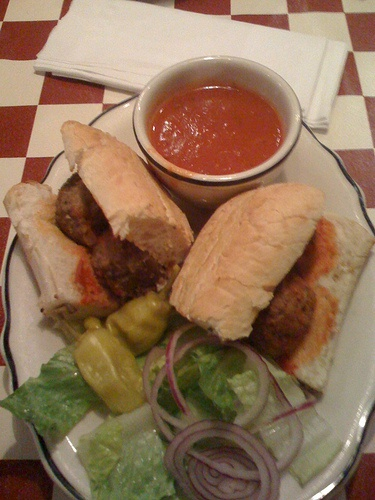Describe the objects in this image and their specific colors. I can see dining table in maroon, olive, tan, and gray tones, sandwich in maroon, tan, and gray tones, sandwich in maroon, tan, and brown tones, and bowl in maroon and brown tones in this image. 